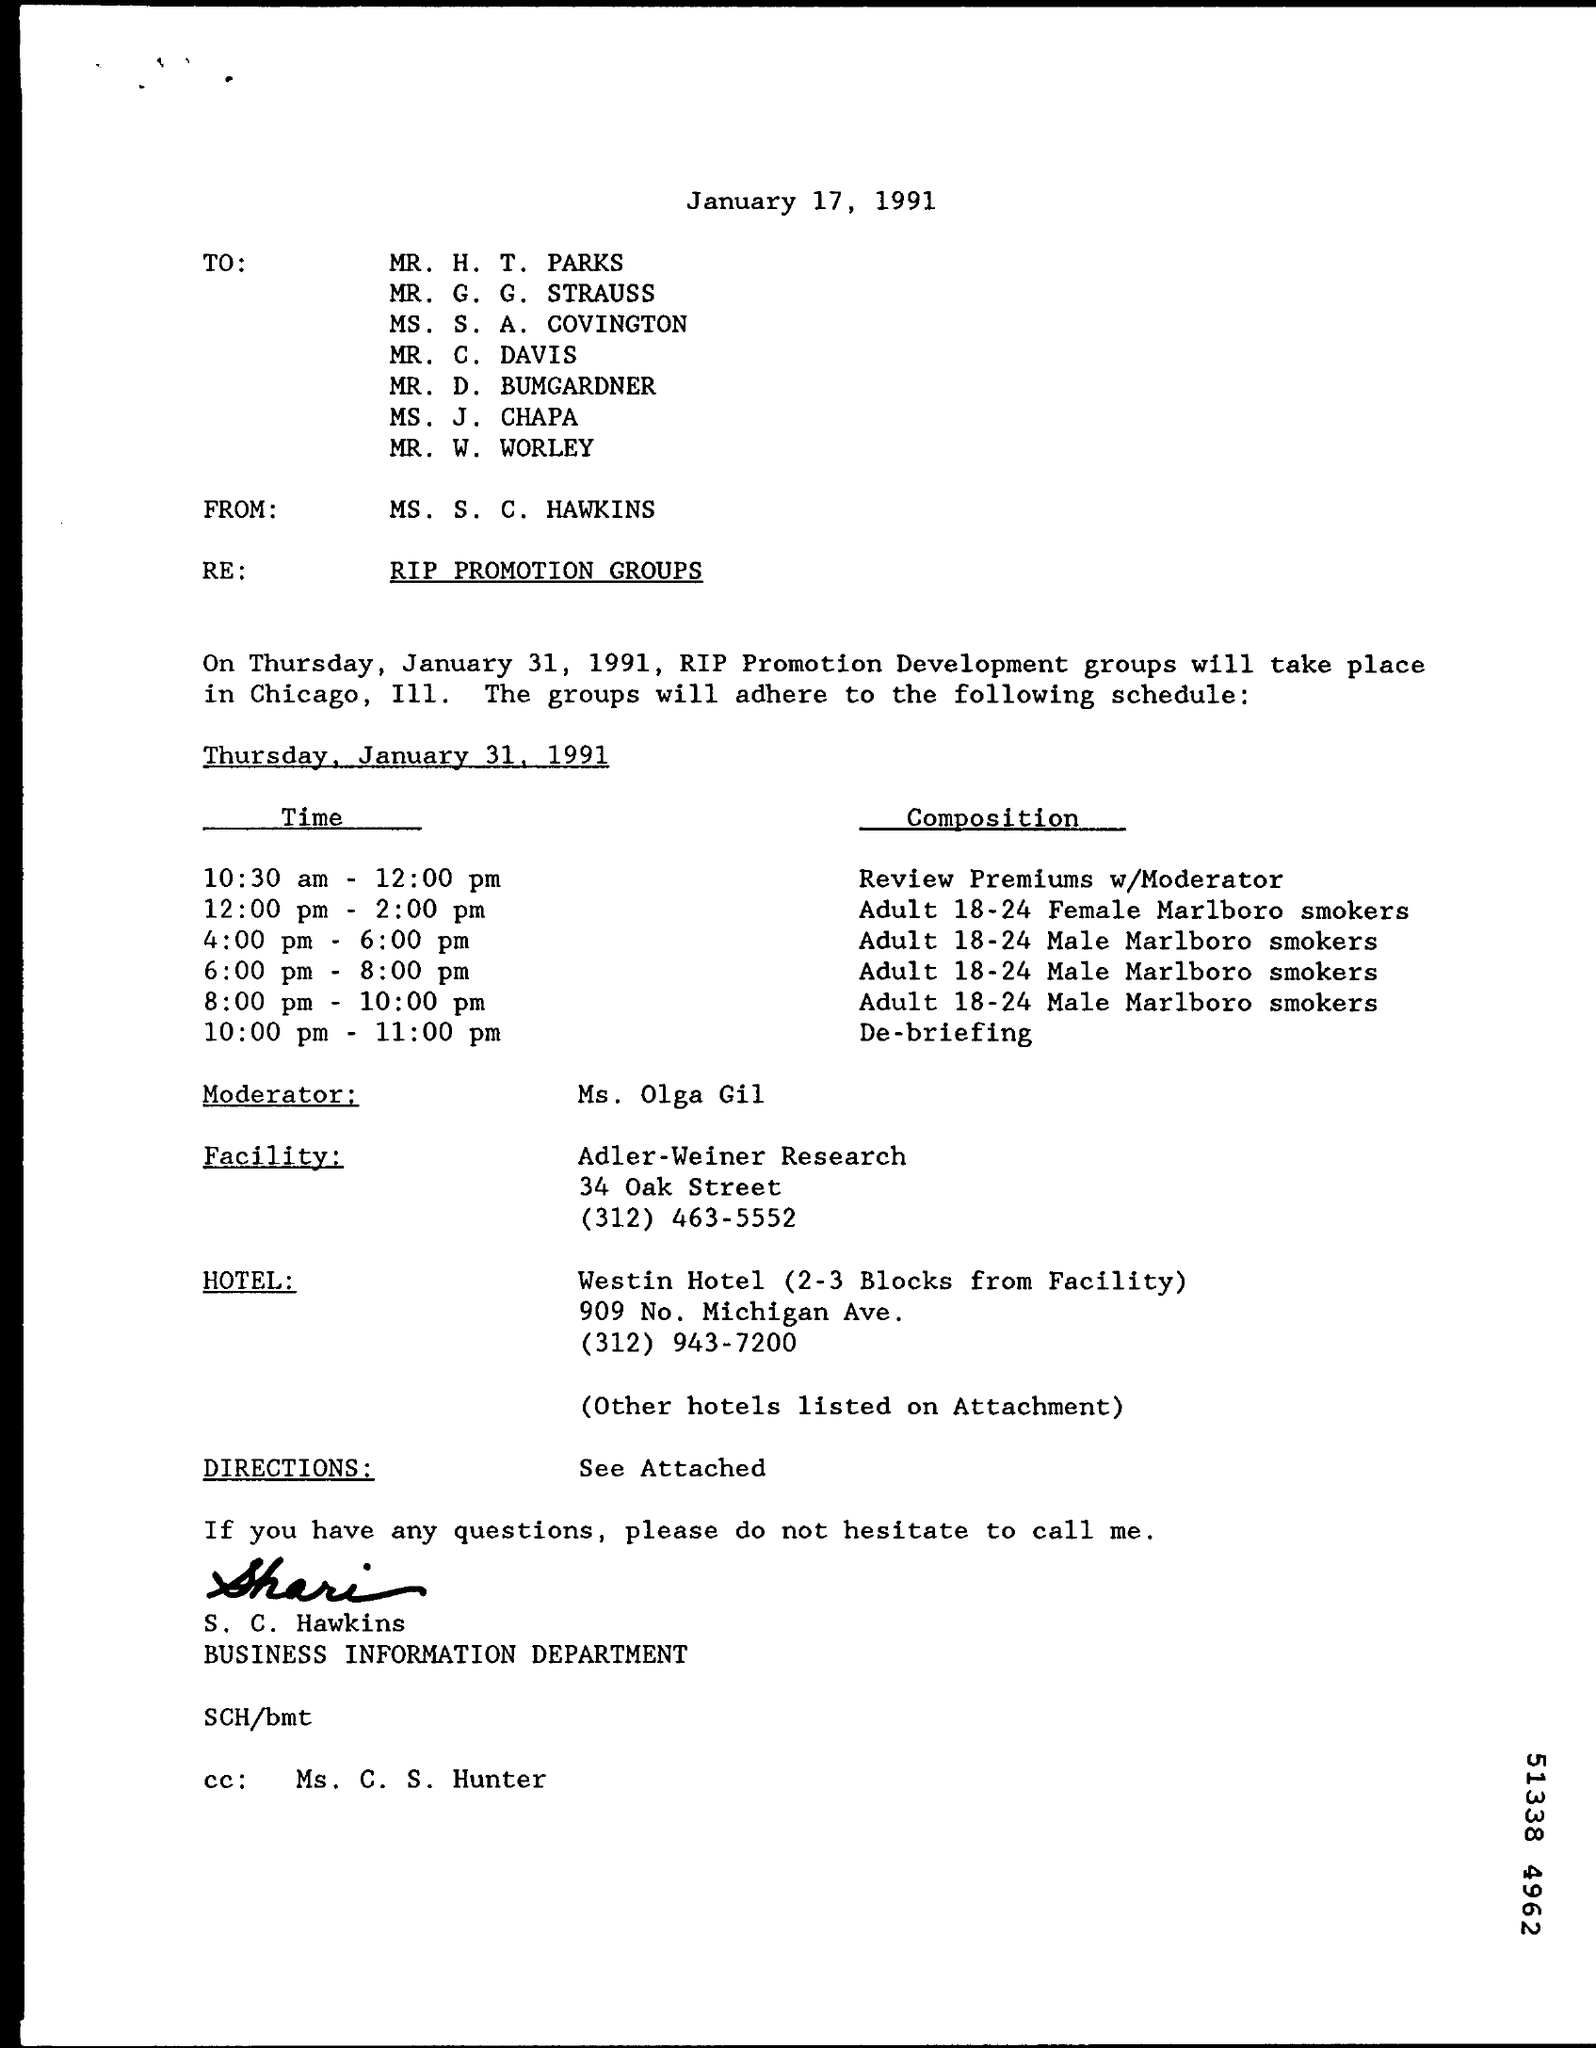From whom this mail was written ?
Offer a terse response. MS . S . C. HAWKINS. On which date this mail was written ?
Your answer should be compact. January 17, 1991. What is the composition at the time of 10:00 pm -11:00 pm?
Provide a succinct answer. De-briefing. Who is the moderator mentioned in the given mail ?
Offer a terse response. Ms. olga gil. What is the composition at the time of 4:00 pm - 6:00 pm ?
Offer a very short reply. Adult 18-24 male marlboro smokers. What is the re mentioned in the given mail ?
Give a very brief answer. RIP promotion groups. 